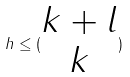Convert formula to latex. <formula><loc_0><loc_0><loc_500><loc_500>h \leq ( \begin{matrix} k + l \\ k \end{matrix} )</formula> 